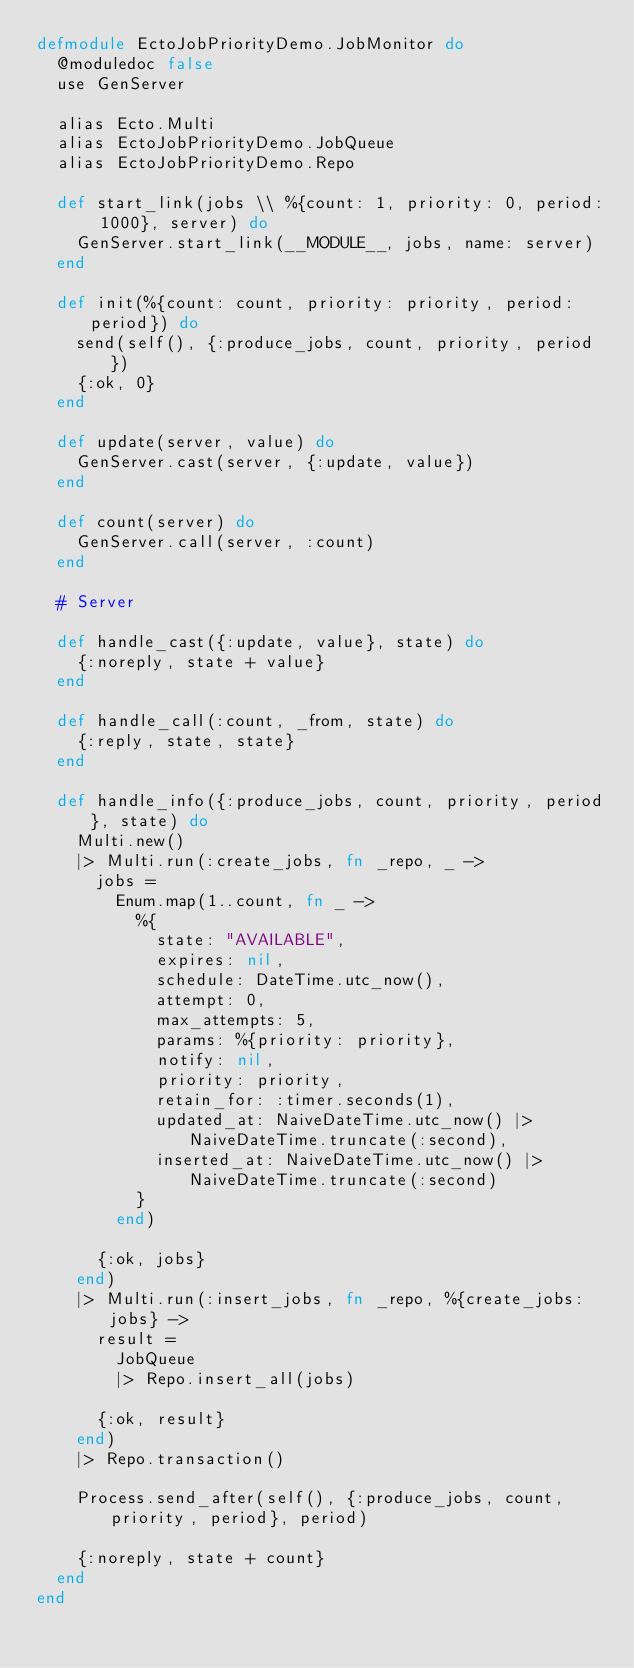Convert code to text. <code><loc_0><loc_0><loc_500><loc_500><_Elixir_>defmodule EctoJobPriorityDemo.JobMonitor do
  @moduledoc false
  use GenServer

  alias Ecto.Multi
  alias EctoJobPriorityDemo.JobQueue
  alias EctoJobPriorityDemo.Repo

  def start_link(jobs \\ %{count: 1, priority: 0, period: 1000}, server) do
    GenServer.start_link(__MODULE__, jobs, name: server)
  end

  def init(%{count: count, priority: priority, period: period}) do
    send(self(), {:produce_jobs, count, priority, period})
    {:ok, 0}
  end

  def update(server, value) do
    GenServer.cast(server, {:update, value})
  end

  def count(server) do
    GenServer.call(server, :count)
  end

  # Server

  def handle_cast({:update, value}, state) do
    {:noreply, state + value}
  end

  def handle_call(:count, _from, state) do
    {:reply, state, state}
  end

  def handle_info({:produce_jobs, count, priority, period}, state) do
    Multi.new()
    |> Multi.run(:create_jobs, fn _repo, _ ->
      jobs =
        Enum.map(1..count, fn _ ->
          %{
            state: "AVAILABLE",
            expires: nil,
            schedule: DateTime.utc_now(),
            attempt: 0,
            max_attempts: 5,
            params: %{priority: priority},
            notify: nil,
            priority: priority,
            retain_for: :timer.seconds(1),
            updated_at: NaiveDateTime.utc_now() |> NaiveDateTime.truncate(:second),
            inserted_at: NaiveDateTime.utc_now() |> NaiveDateTime.truncate(:second)
          }
        end)

      {:ok, jobs}
    end)
    |> Multi.run(:insert_jobs, fn _repo, %{create_jobs: jobs} ->
      result =
        JobQueue
        |> Repo.insert_all(jobs)

      {:ok, result}
    end)
    |> Repo.transaction()

    Process.send_after(self(), {:produce_jobs, count, priority, period}, period)

    {:noreply, state + count}
  end
end
</code> 